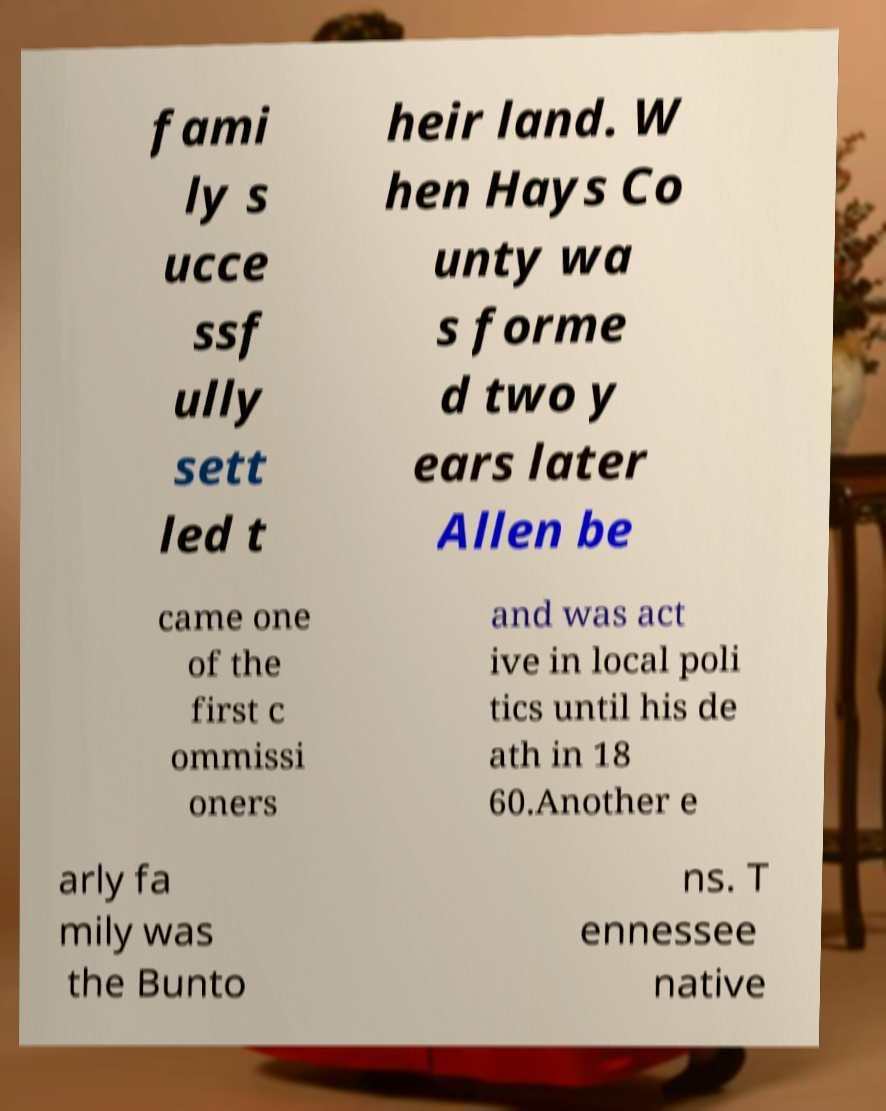There's text embedded in this image that I need extracted. Can you transcribe it verbatim? fami ly s ucce ssf ully sett led t heir land. W hen Hays Co unty wa s forme d two y ears later Allen be came one of the first c ommissi oners and was act ive in local poli tics until his de ath in 18 60.Another e arly fa mily was the Bunto ns. T ennessee native 